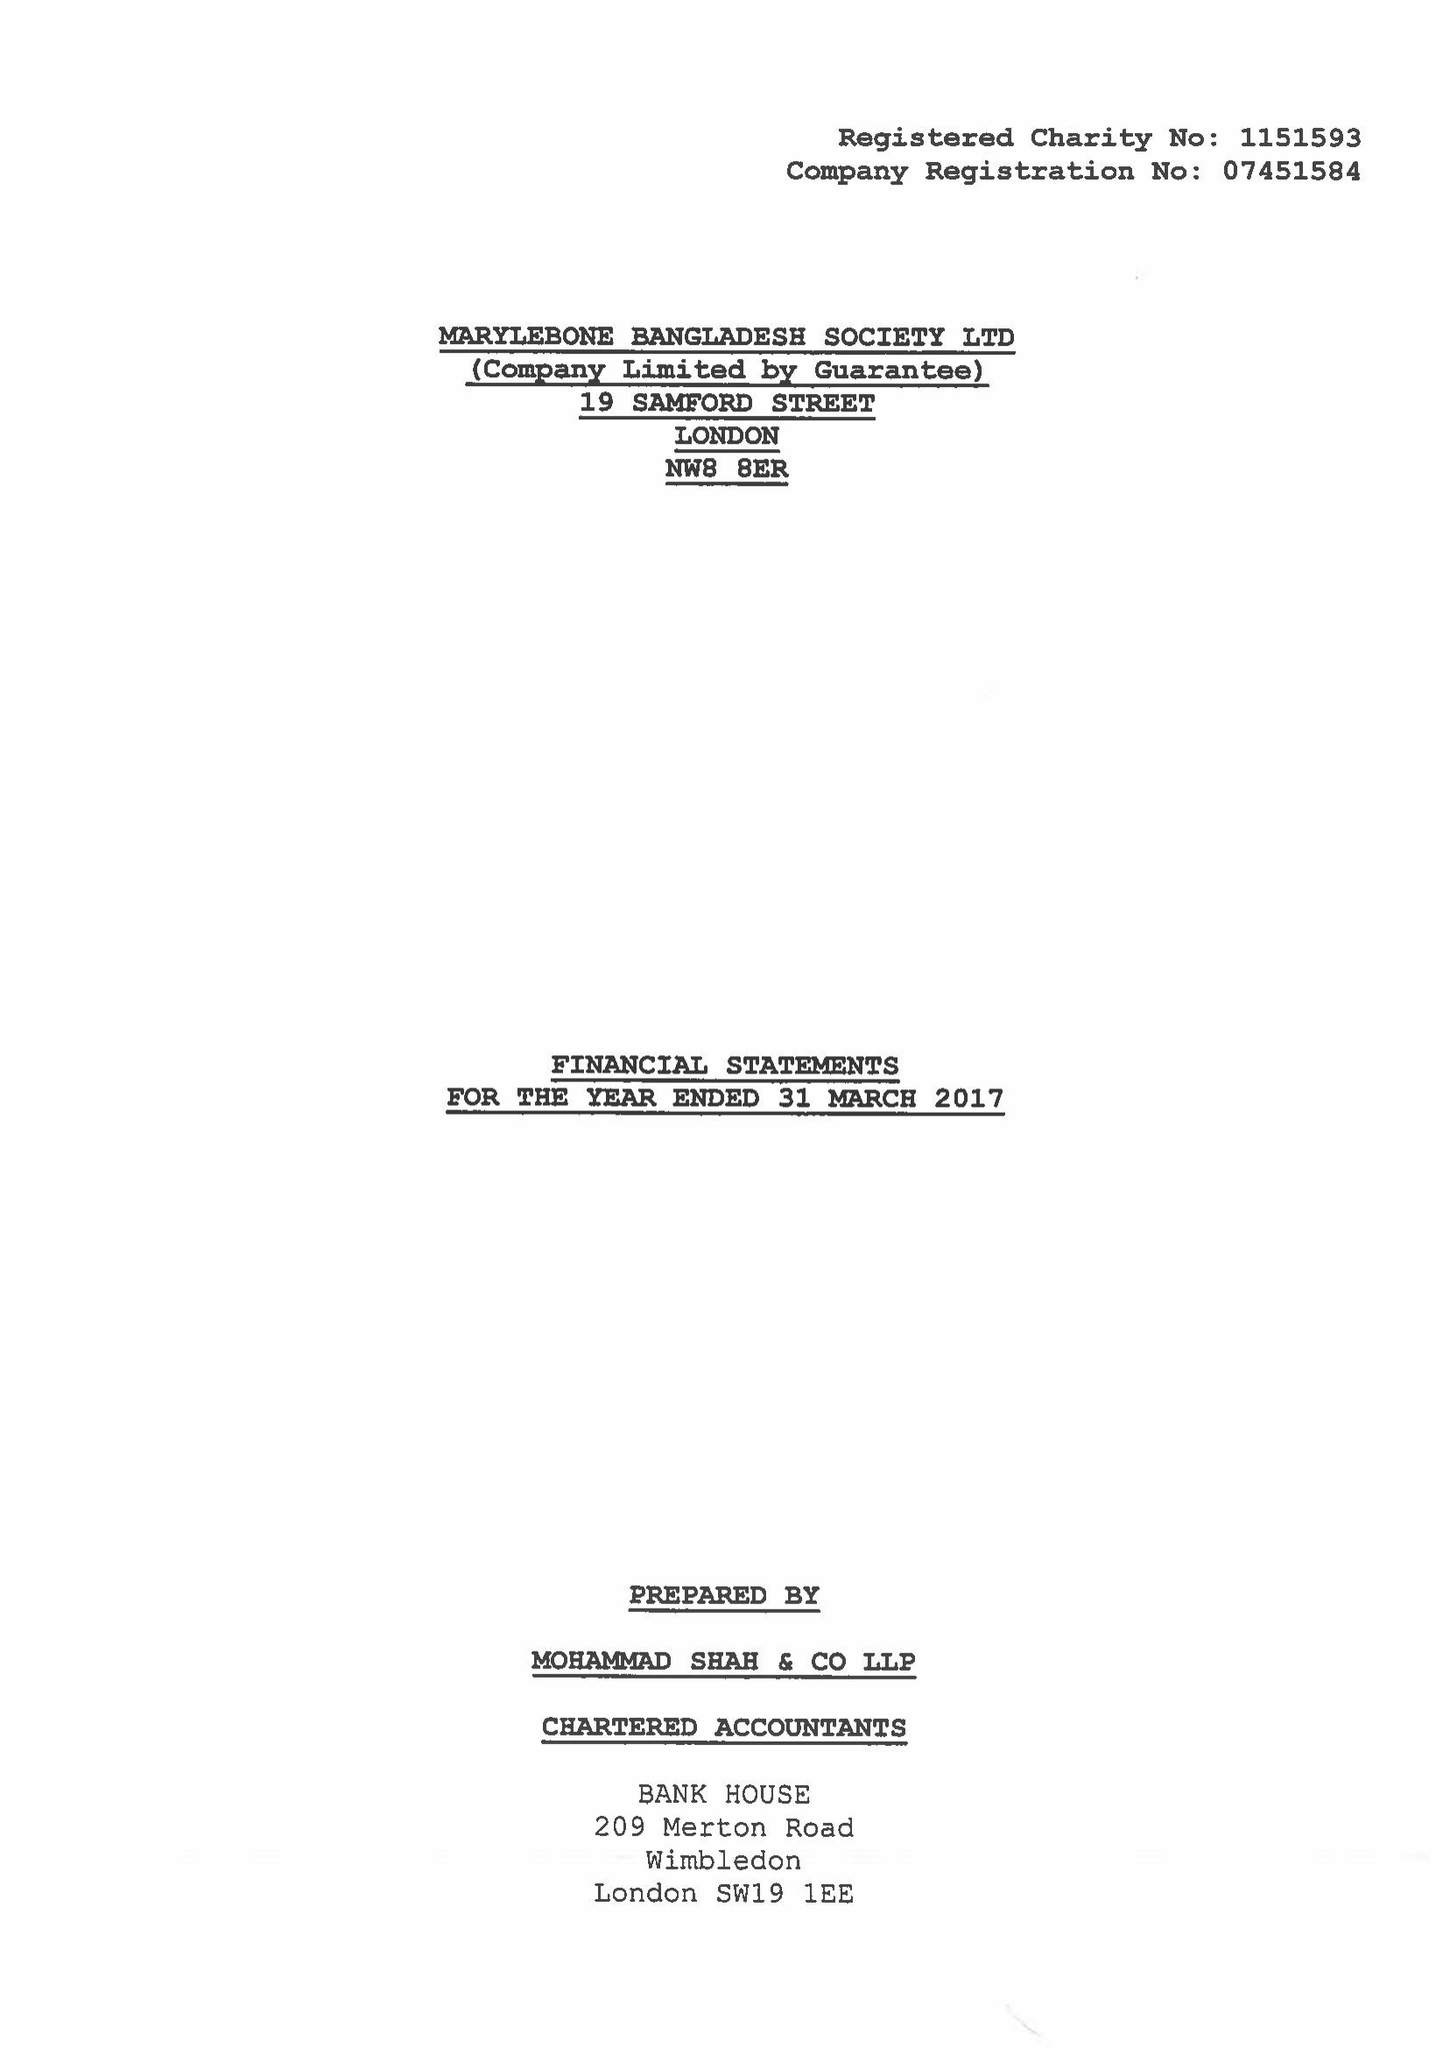What is the value for the spending_annually_in_british_pounds?
Answer the question using a single word or phrase. 164387.00 